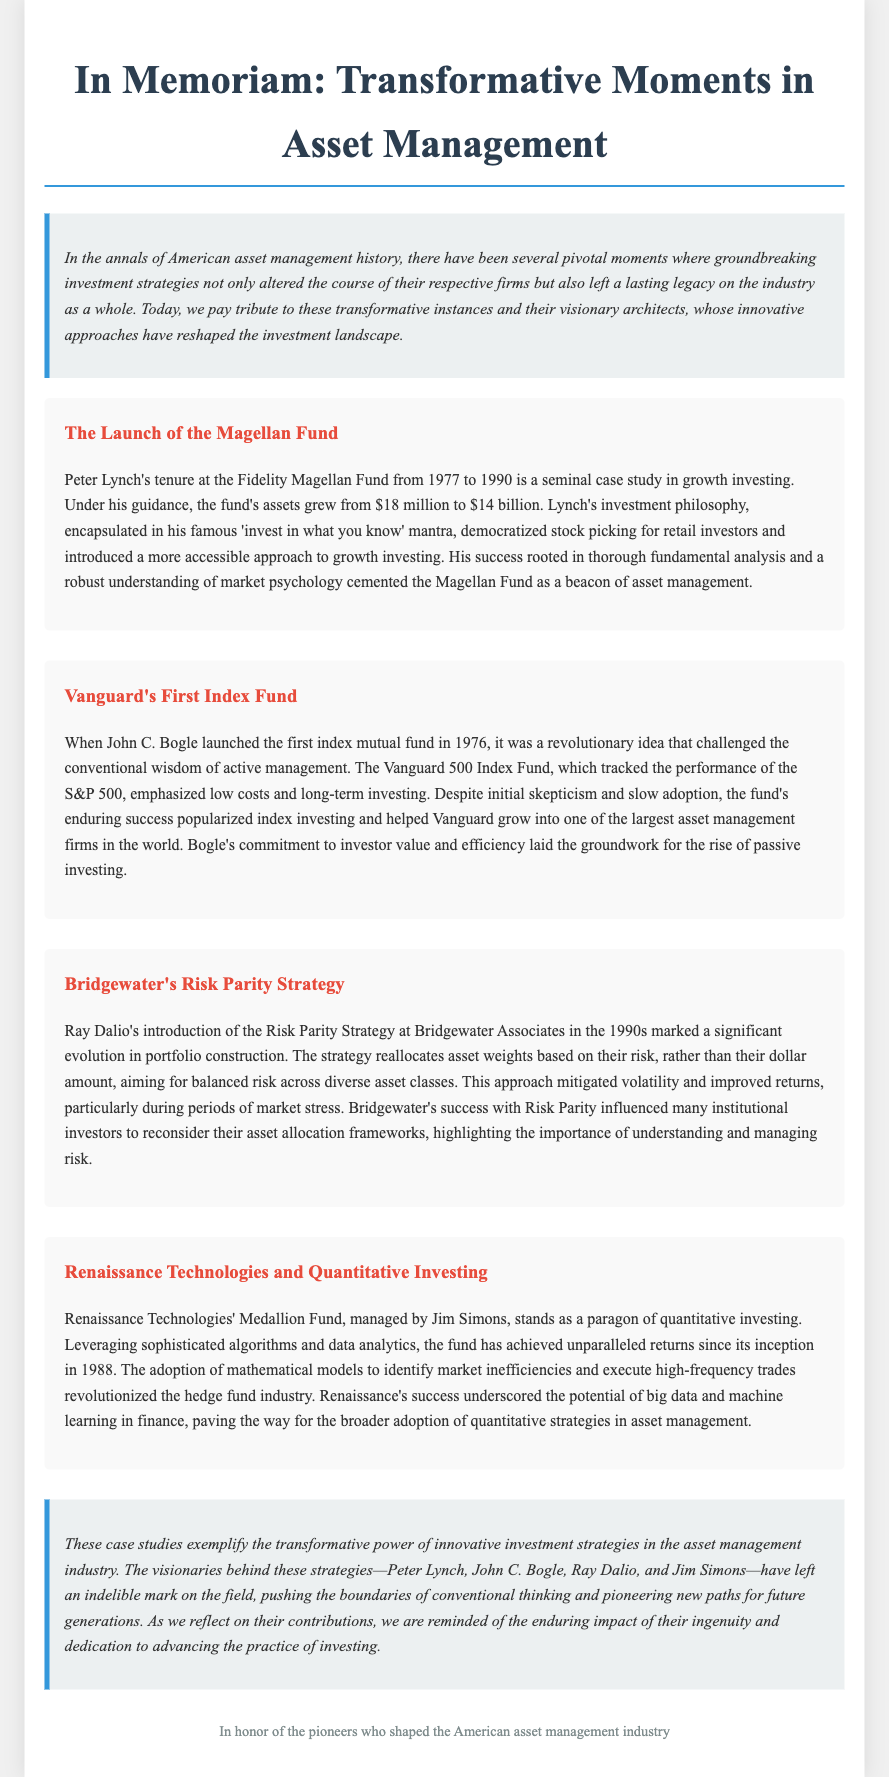what year did Peter Lynch's tenure at the Fidelity Magellan Fund start? The document states that Peter Lynch's tenure began in 1977.
Answer: 1977 what was the asset growth of the Magellan Fund under Peter Lynch? The document mentions that the fund's assets grew from $18 million to $14 billion during Lynch's tenure.
Answer: $14 billion who launched the first index mutual fund? According to the document, the first index mutual fund was launched by John C. Bogle.
Answer: John C. Bogle what innovative strategy did Ray Dalio introduce at Bridgewater Associates? The document describes Ray Dalio's introduction of the Risk Parity Strategy as a significant evolution in portfolio construction.
Answer: Risk Parity Strategy how much did Renaissance Technologies' Medallion Fund achieve in returns since its inception? The text highlights that the Medallion Fund has achieved unparalleled returns since its inception in 1988.
Answer: Unparalleled returns what fundamental principle did Peter Lynch highlight in his investment philosophy? The document cites Lynch's famous mantra, "invest in what you know," as a key principle of his investment philosophy.
Answer: Invest in what you know which index does the Vanguard 500 Index Fund track? The document states that the Vanguard 500 Index Fund tracked the performance of the S&P 500.
Answer: S&P 500 what was the primary focus of John C. Bogle's investment philosophy? The document indicates that Bogle emphasized low costs and long-term investing in his strategy.
Answer: Low costs and long-term investing what did the success of Renaissance Technologies underscore about big data in finance? The document notes that Renaissance's success underscored the potential of big data and machine learning in finance.
Answer: Big data and machine learning 